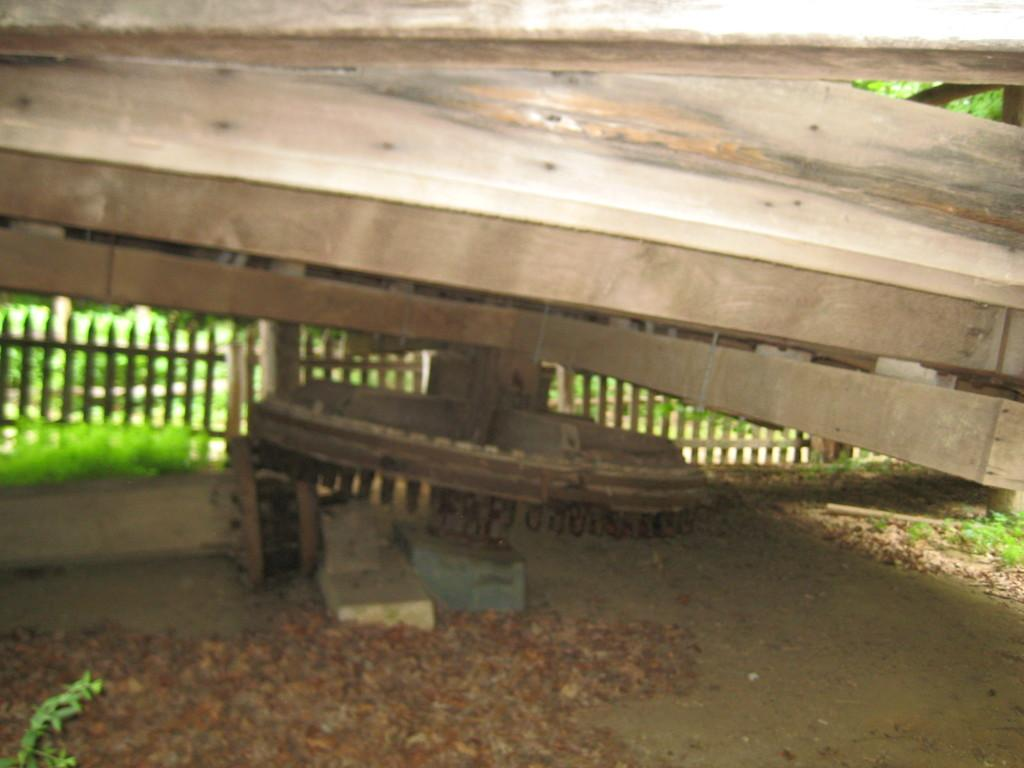What structure is located in the center of the image? There is a wooden bridge in the center of the image. What can be seen in the background of the image? There are trees and a fence in the background of the image. What is visible at the bottom of the image? The ground is visible at the bottom of the image. What type of produce is being sold by the kitty in the image? There is no kitty or produce present in the image. How is the rice being prepared in the image? There is no rice present in the image. 